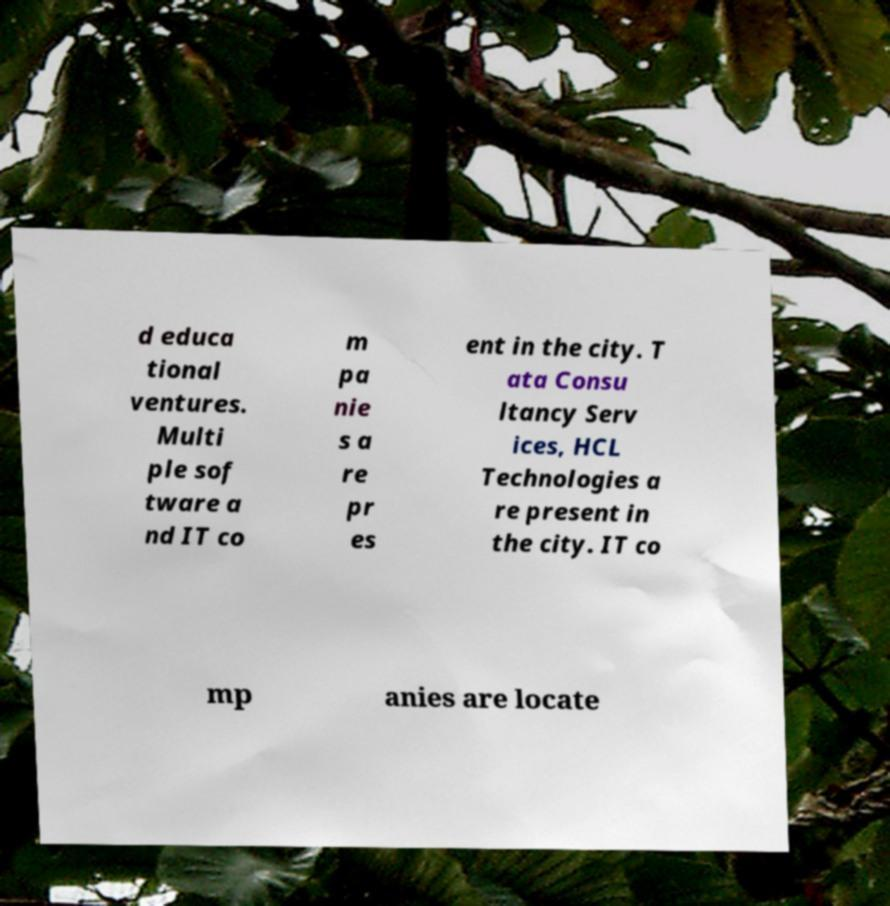There's text embedded in this image that I need extracted. Can you transcribe it verbatim? d educa tional ventures. Multi ple sof tware a nd IT co m pa nie s a re pr es ent in the city. T ata Consu ltancy Serv ices, HCL Technologies a re present in the city. IT co mp anies are locate 